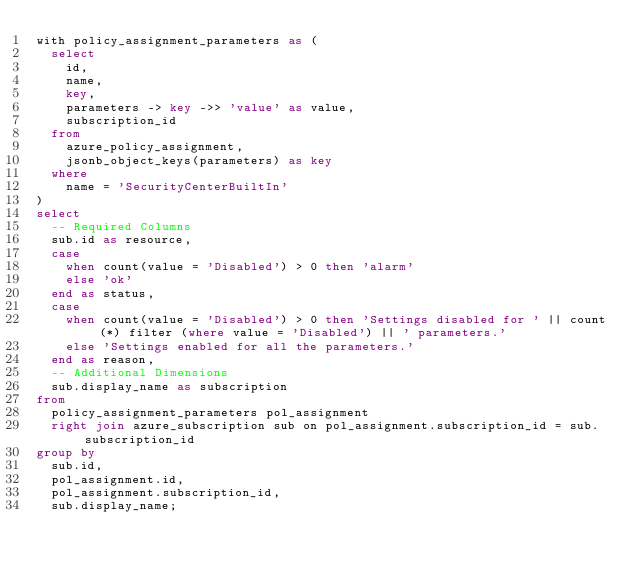Convert code to text. <code><loc_0><loc_0><loc_500><loc_500><_SQL_>with policy_assignment_parameters as (
  select
    id,
    name,
    key,
    parameters -> key ->> 'value' as value,
    subscription_id
  from
    azure_policy_assignment,
    jsonb_object_keys(parameters) as key
  where
    name = 'SecurityCenterBuiltIn'
)
select
  -- Required Columns
  sub.id as resource,
  case
    when count(value = 'Disabled') > 0 then 'alarm'
    else 'ok'
  end as status,
  case
    when count(value = 'Disabled') > 0 then 'Settings disabled for ' || count(*) filter (where value = 'Disabled') || ' parameters.'
    else 'Settings enabled for all the parameters.'
  end as reason,
  -- Additional Dimensions
  sub.display_name as subscription
from
  policy_assignment_parameters pol_assignment
  right join azure_subscription sub on pol_assignment.subscription_id = sub.subscription_id
group by
  sub.id,
  pol_assignment.id,
  pol_assignment.subscription_id,
  sub.display_name;</code> 